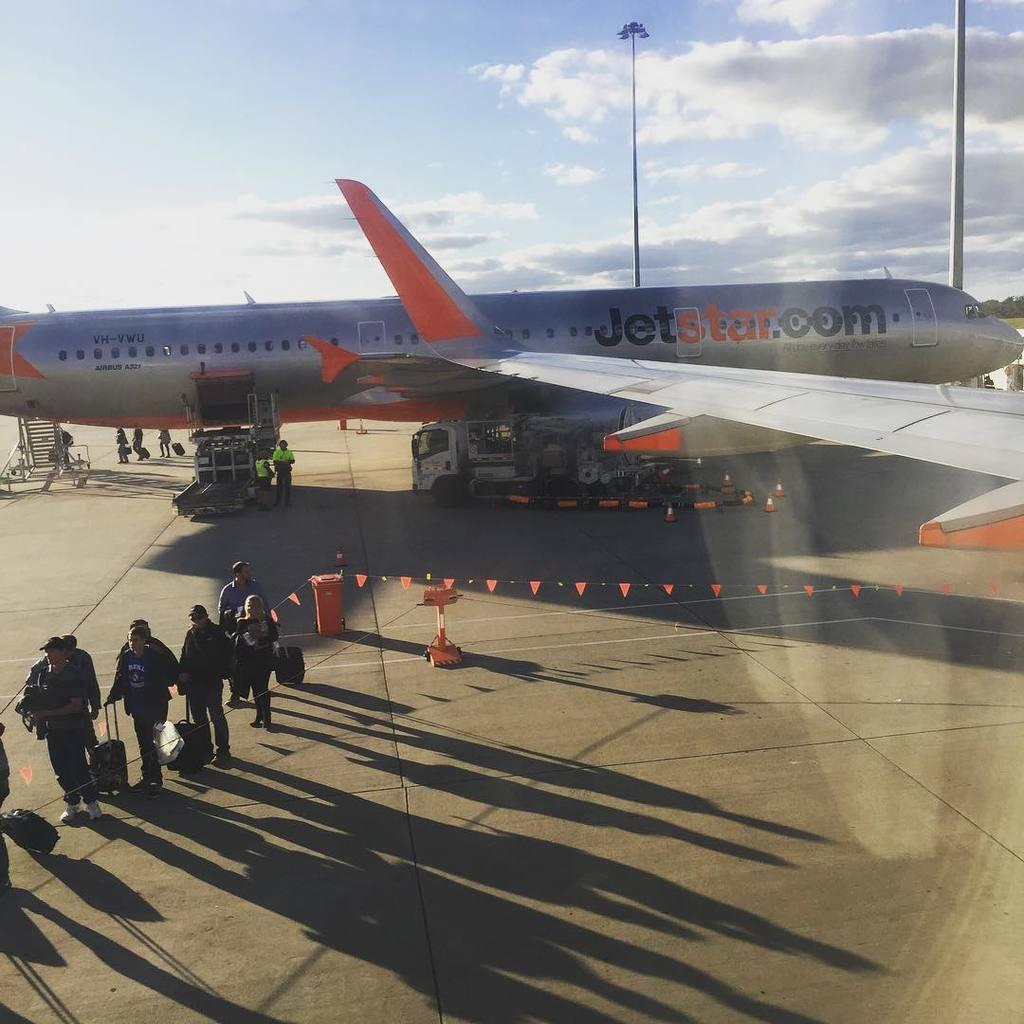<image>
Render a clear and concise summary of the photo. People outside standing in line with luggage with a large Jetstar plane in the background. 